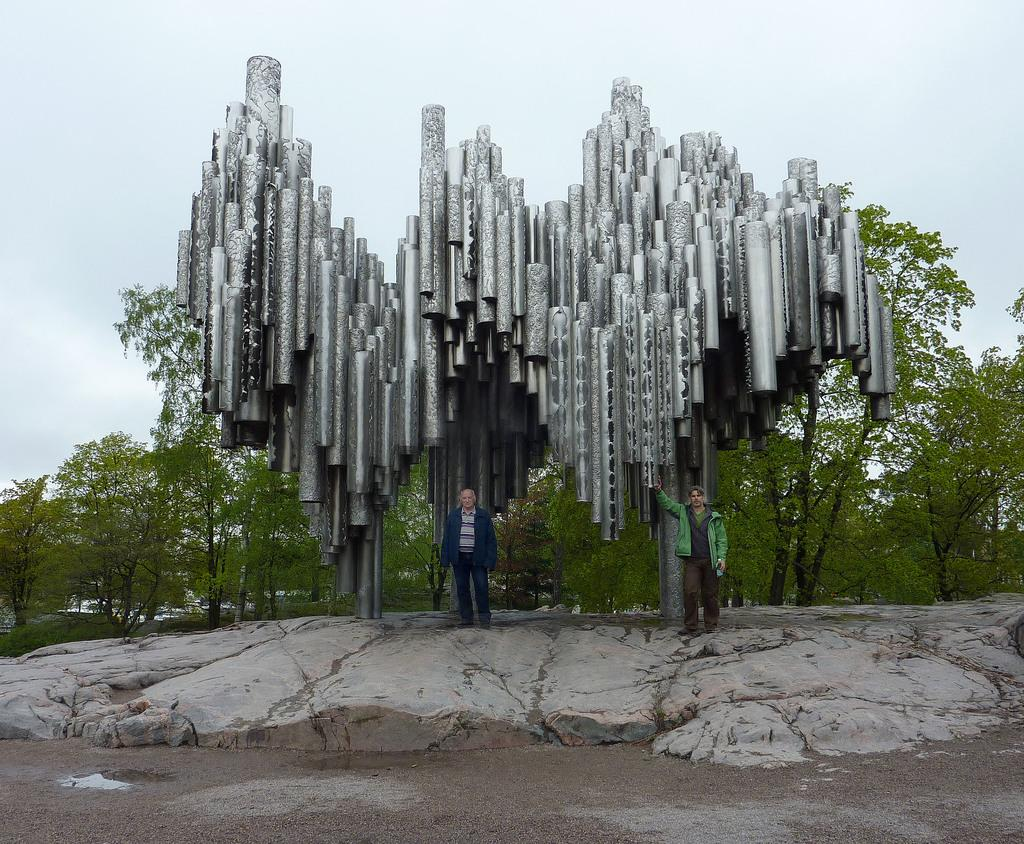How many people are in the image? There are two persons in the image. What are the persons doing in the image? The persons are standing under some structure. What can be seen in the background of the image? There are trees and the sky visible in the background of the image. What type of food is being served to the visitor in the image? There is no food or visitor present in the image. What scientific discovery is being discussed by the persons in the image? There is no indication of a scientific discussion in the image. 